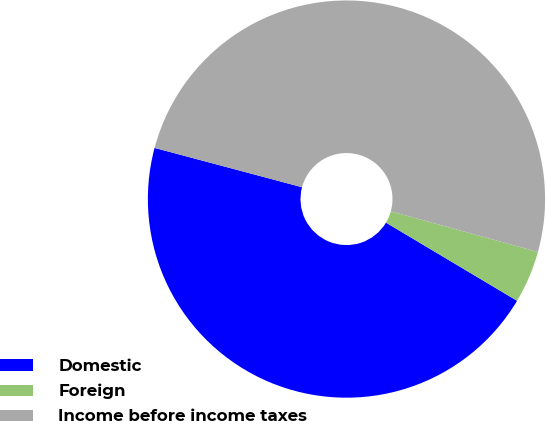Convert chart. <chart><loc_0><loc_0><loc_500><loc_500><pie_chart><fcel>Domestic<fcel>Foreign<fcel>Income before income taxes<nl><fcel>45.59%<fcel>4.27%<fcel>50.14%<nl></chart> 